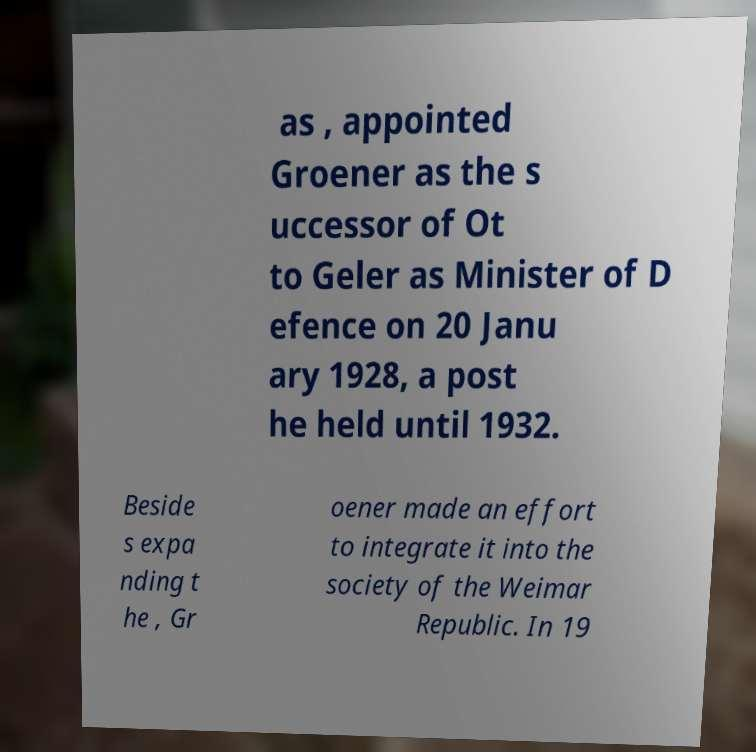Please identify and transcribe the text found in this image. as , appointed Groener as the s uccessor of Ot to Geler as Minister of D efence on 20 Janu ary 1928, a post he held until 1932. Beside s expa nding t he , Gr oener made an effort to integrate it into the society of the Weimar Republic. In 19 